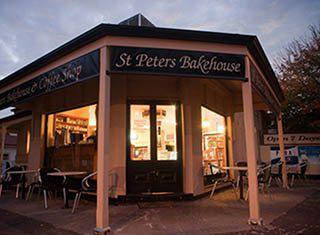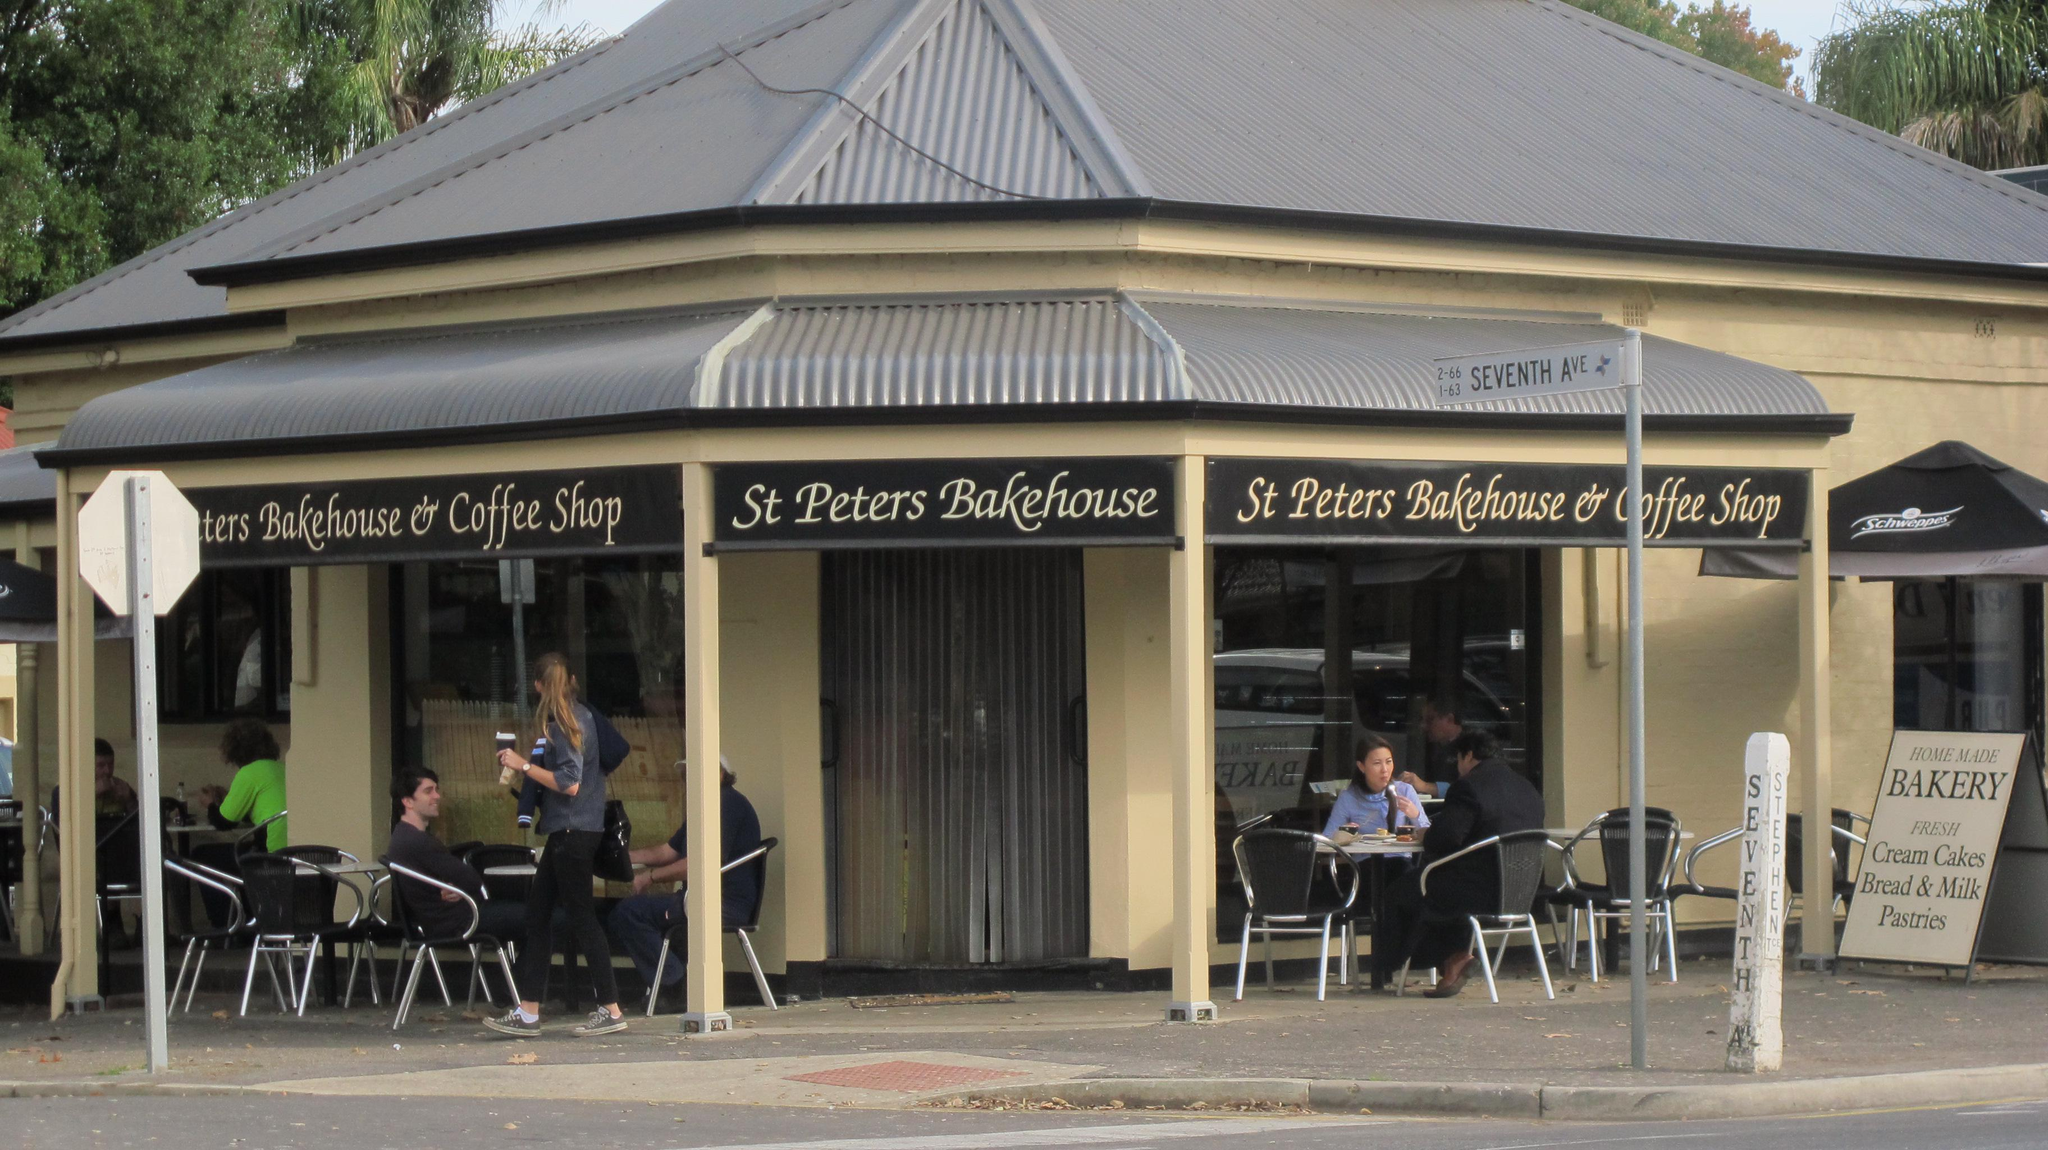The first image is the image on the left, the second image is the image on the right. For the images displayed, is the sentence "We can see the outdoor seats to the restaurant." factually correct? Answer yes or no. Yes. 